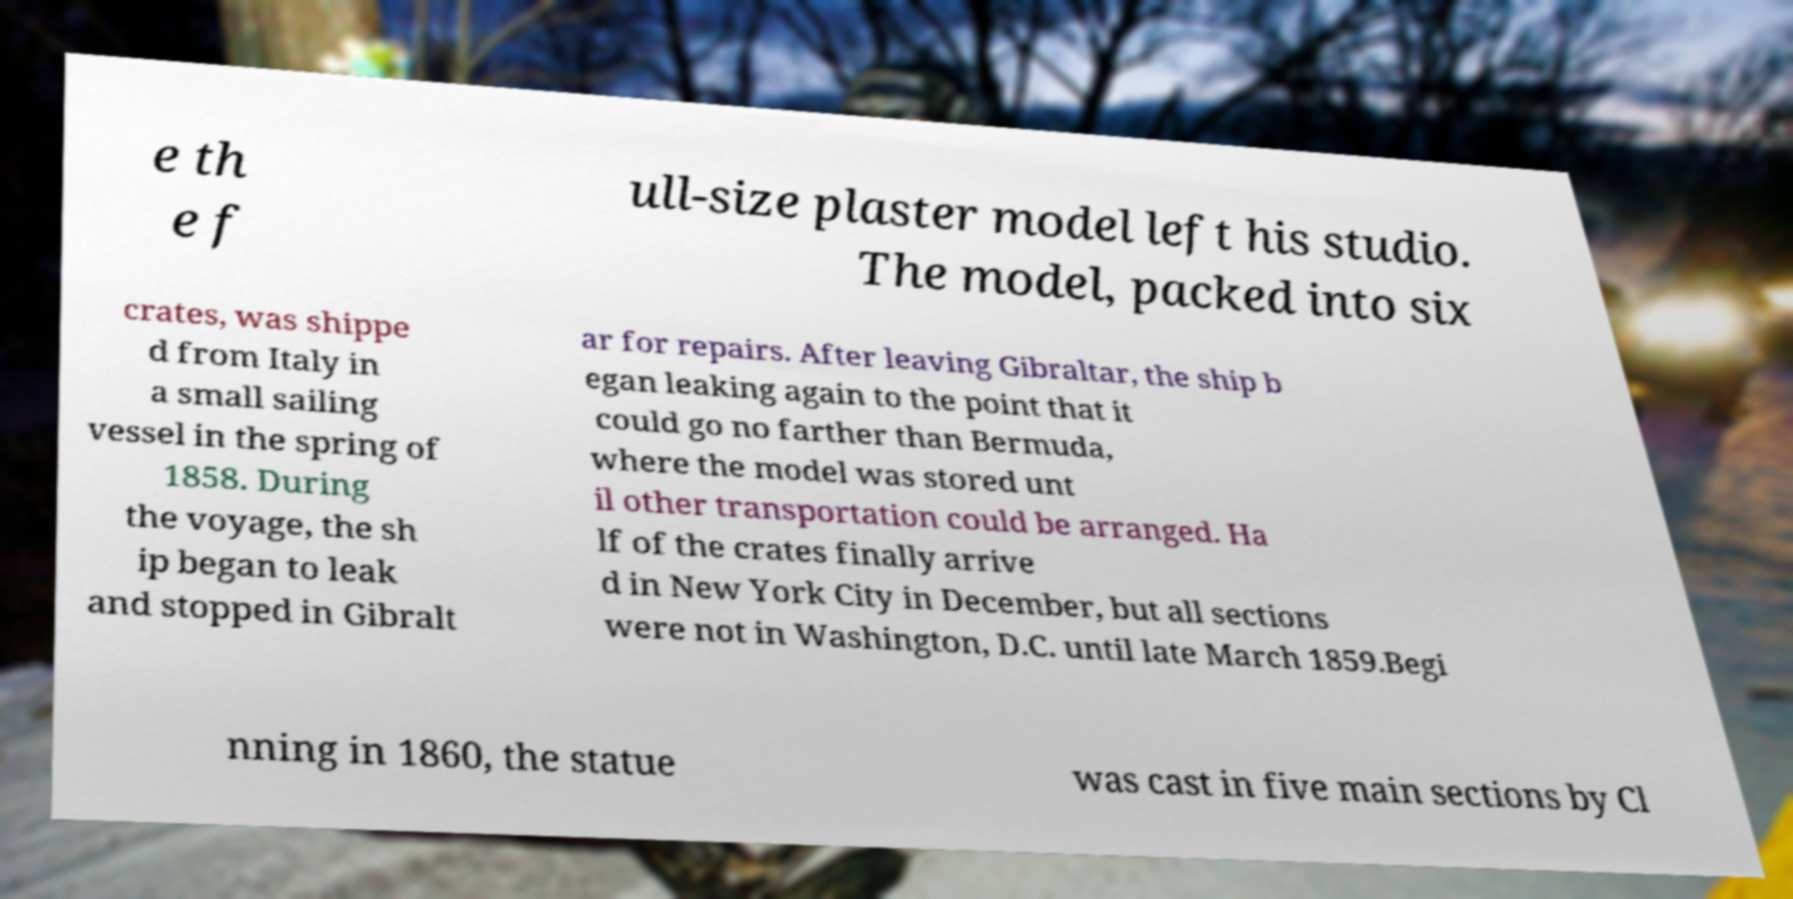Could you extract and type out the text from this image? e th e f ull-size plaster model left his studio. The model, packed into six crates, was shippe d from Italy in a small sailing vessel in the spring of 1858. During the voyage, the sh ip began to leak and stopped in Gibralt ar for repairs. After leaving Gibraltar, the ship b egan leaking again to the point that it could go no farther than Bermuda, where the model was stored unt il other transportation could be arranged. Ha lf of the crates finally arrive d in New York City in December, but all sections were not in Washington, D.C. until late March 1859.Begi nning in 1860, the statue was cast in five main sections by Cl 